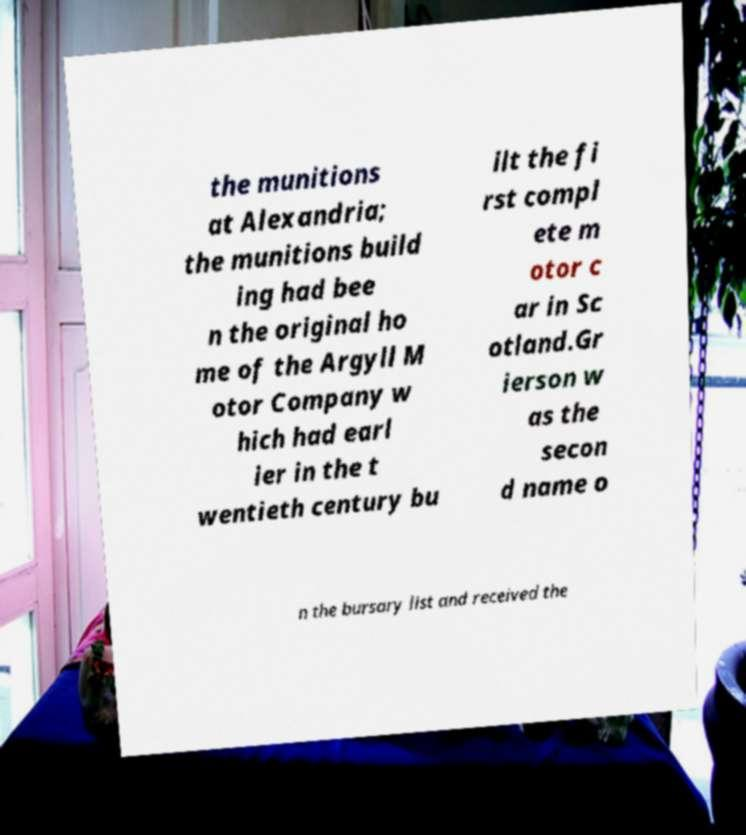For documentation purposes, I need the text within this image transcribed. Could you provide that? the munitions at Alexandria; the munitions build ing had bee n the original ho me of the Argyll M otor Company w hich had earl ier in the t wentieth century bu ilt the fi rst compl ete m otor c ar in Sc otland.Gr ierson w as the secon d name o n the bursary list and received the 